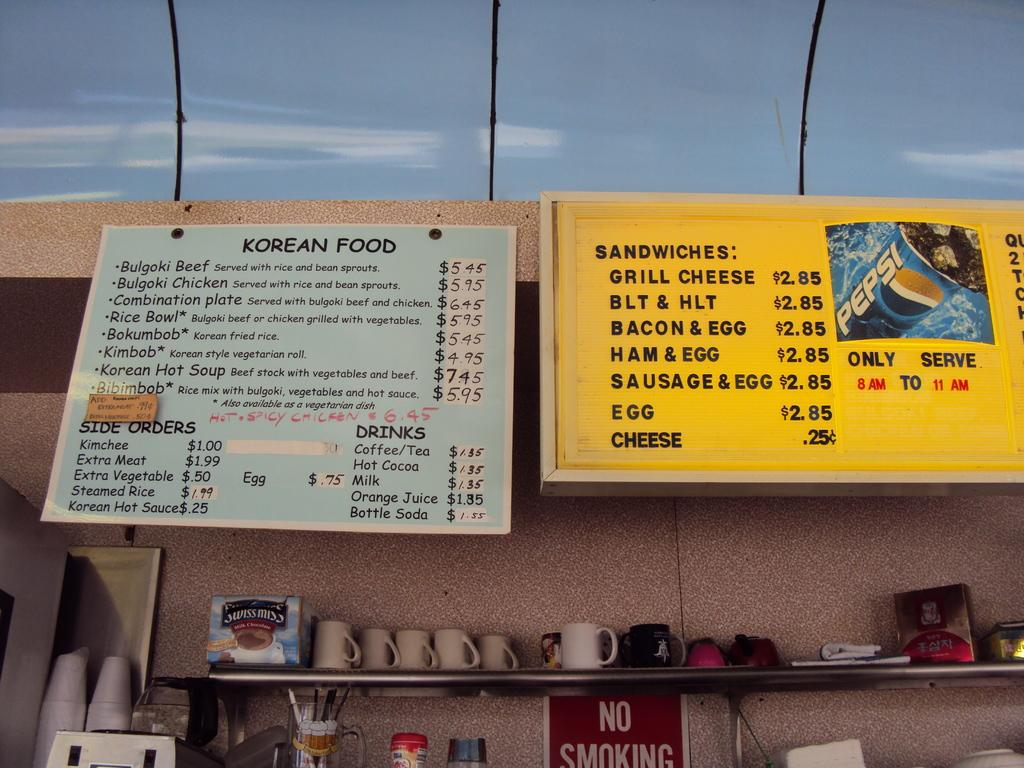<image>
Summarize the visual content of the image. Outdoor menu display board with Korean Food as the header. 